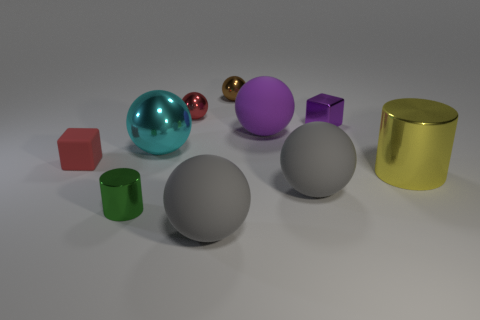The other shiny thing that is the same shape as the small green thing is what color?
Offer a terse response. Yellow. Is the red thing that is in front of the large metallic sphere made of the same material as the purple object in front of the shiny cube?
Offer a terse response. Yes. What is the shape of the other object that is the same color as the tiny rubber object?
Your response must be concise. Sphere. What number of objects are big things behind the yellow thing or things in front of the purple shiny object?
Offer a terse response. 7. There is a cylinder that is on the right side of the cyan sphere; is its color the same as the matte object on the left side of the big cyan ball?
Make the answer very short. No. The matte object that is behind the big yellow shiny cylinder and on the right side of the green metallic cylinder has what shape?
Offer a terse response. Sphere. What color is the matte thing that is the same size as the green shiny object?
Keep it short and to the point. Red. Are there any big matte spheres of the same color as the small cylinder?
Offer a terse response. No. Do the metallic thing right of the tiny purple metallic thing and the red object that is behind the red block have the same size?
Your answer should be very brief. No. The ball that is both in front of the metallic block and behind the cyan ball is made of what material?
Ensure brevity in your answer.  Rubber. 